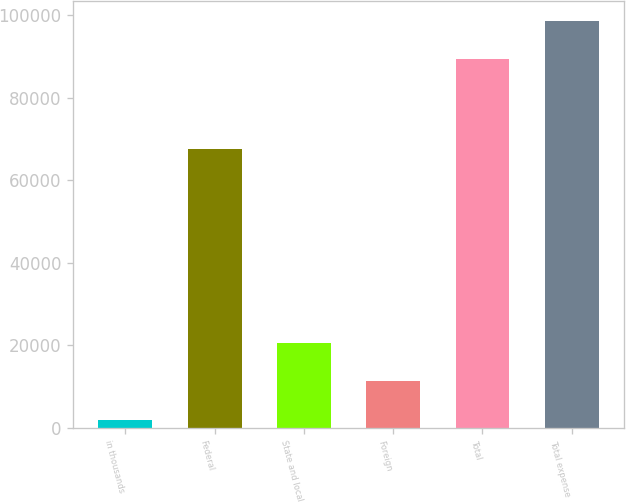Convert chart to OTSL. <chart><loc_0><loc_0><loc_500><loc_500><bar_chart><fcel>in thousands<fcel>Federal<fcel>State and local<fcel>Foreign<fcel>Total<fcel>Total expense<nl><fcel>2015<fcel>67521<fcel>20600.6<fcel>11307.8<fcel>89340<fcel>98632.8<nl></chart> 